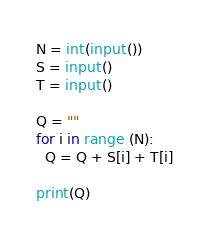Convert code to text. <code><loc_0><loc_0><loc_500><loc_500><_Python_>N = int(input())
S = input()
T = input()
 
Q = ""
for i in range (N):
  Q = Q + S[i] + T[i]
  
print(Q)</code> 